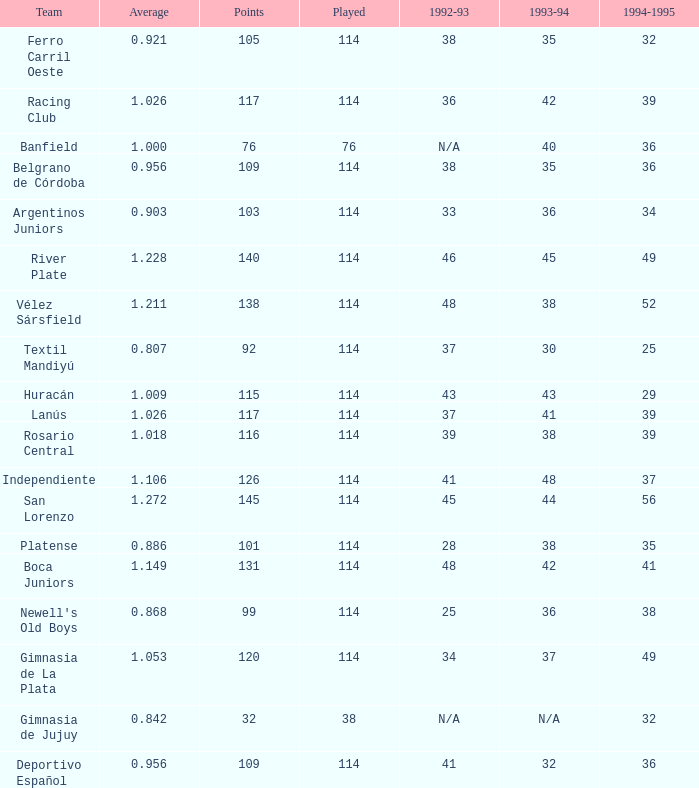Name the team for 1993-94 for 32 Deportivo Español. Could you parse the entire table? {'header': ['Team', 'Average', 'Points', 'Played', '1992-93', '1993-94', '1994-1995'], 'rows': [['Ferro Carril Oeste', '0.921', '105', '114', '38', '35', '32'], ['Racing Club', '1.026', '117', '114', '36', '42', '39'], ['Banfield', '1.000', '76', '76', 'N/A', '40', '36'], ['Belgrano de Córdoba', '0.956', '109', '114', '38', '35', '36'], ['Argentinos Juniors', '0.903', '103', '114', '33', '36', '34'], ['River Plate', '1.228', '140', '114', '46', '45', '49'], ['Vélez Sársfield', '1.211', '138', '114', '48', '38', '52'], ['Textil Mandiyú', '0.807', '92', '114', '37', '30', '25'], ['Huracán', '1.009', '115', '114', '43', '43', '29'], ['Lanús', '1.026', '117', '114', '37', '41', '39'], ['Rosario Central', '1.018', '116', '114', '39', '38', '39'], ['Independiente', '1.106', '126', '114', '41', '48', '37'], ['San Lorenzo', '1.272', '145', '114', '45', '44', '56'], ['Platense', '0.886', '101', '114', '28', '38', '35'], ['Boca Juniors', '1.149', '131', '114', '48', '42', '41'], ["Newell's Old Boys", '0.868', '99', '114', '25', '36', '38'], ['Gimnasia de La Plata', '1.053', '120', '114', '34', '37', '49'], ['Gimnasia de Jujuy', '0.842', '32', '38', 'N/A', 'N/A', '32'], ['Deportivo Español', '0.956', '109', '114', '41', '32', '36']]} 